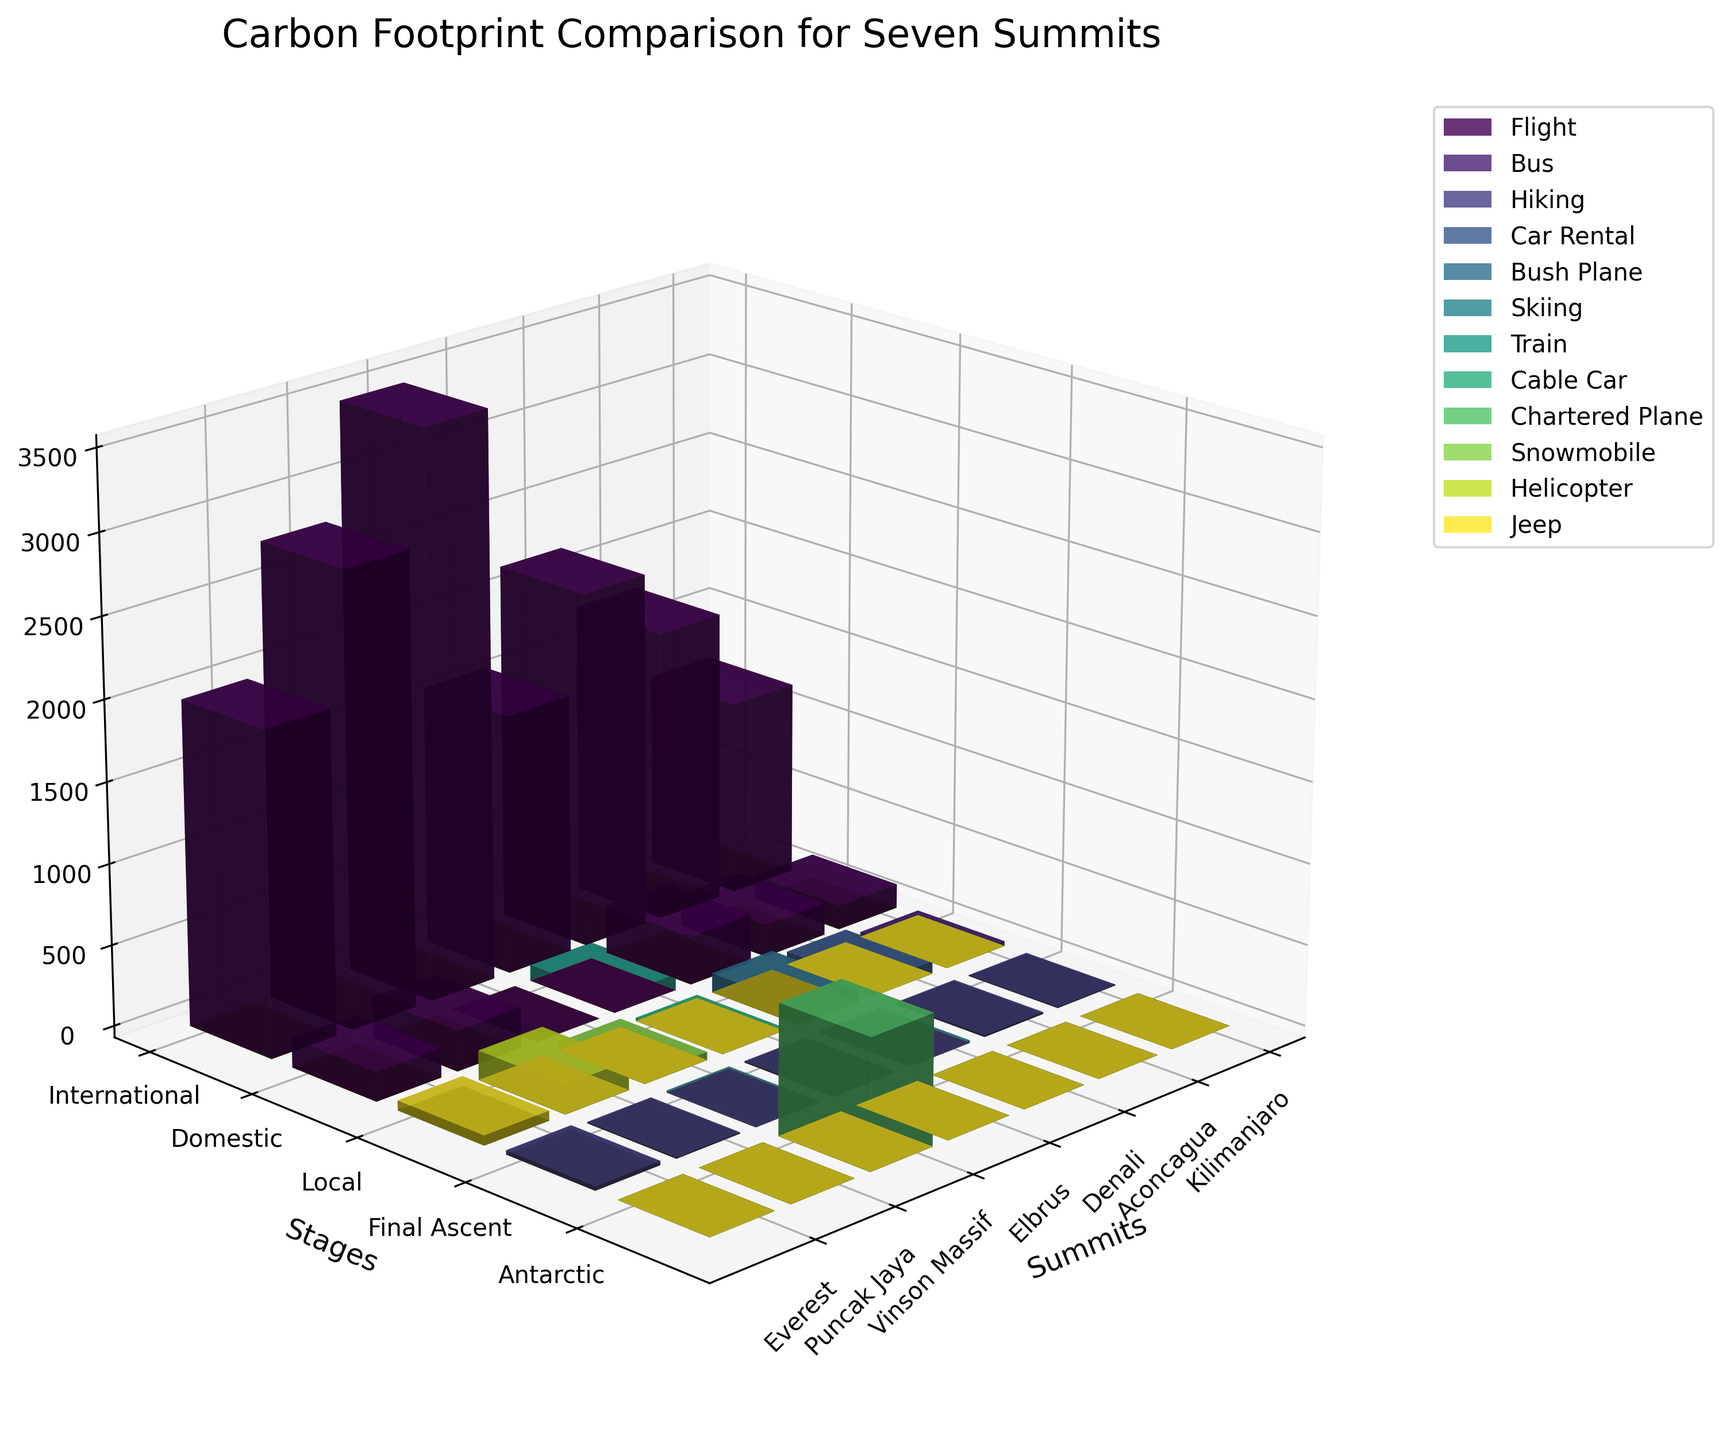1. What is the title of the figure? The title is generally displayed at the top of the figure, which helps in understanding the overall content being represented.
Answer: Carbon Footprint Comparison for Seven Summits 2. Which stage has the highest carbon footprint for Vinson Massif? By examining the bars corresponding to each stage for Vinson Massif, look for the tallest bar which represents the highest carbon footprint. The stages are labeled on the y-axis, and the carbon footprints are shown on the z-axis.
Answer: International 3. How does the carbon footprint of the Domestic Flight stage for Denali compare to that of Everest? Find the bars corresponding to the Domestic Flight stage for both Denali and Everest, and compare their heights as depicted from the base to the top in the z-axis.
Answer: Denali's Domestic Flight has a higher carbon footprint than Everest 4. Which transport method contributes the least carbon footprint when climbing Kilimanjaro? Identify the shortest bar for Kilimanjaro across all transport methods, as the shortest bar represents the minimum carbon footprint. Verify by checking the colors in the legend.
Answer: Hiking 5. What is the combined carbon footprint for all stages when climbing Elbrus? Sum the heights of the bars for Elbrus across all stages listed: International Flight, Domestic Train, Local Cable Car, and Final Ascent Hiking. Their contributions are shown on the z-axis in kg CO2e.
Answer: 1720 kg CO2e 6. Which summit has the highest carbon footprint from Local transport methods? Compare the heights of the bars representing local transport methods (e.g., Bus, Car Rental, Bush Plane, Cable Car, Snowmobile, Helicopter, Jeep) across all summits to identify the tallest.
Answer: Puncak Jaya 7. How do the carbon footprints of the Final Ascent stage vary across summits? Look at the bars for the Final Ascent stage for each summit listed, observe and note the differences in their heights.
Answer: Kilimanjaro: 5, Aconcagua: 10, Denali: 15, Elbrus: 8, Vinson Massif: 12, Puncak Jaya: 7, Everest: 25 8. What is the total carbon footprint for the International Flight stage across all summits? Find the bars representing the International Flight stage for each summit, sum the heights, which represent their respective carbon footprints.
Answer: 15100 kg CO2e 9. How much greater is the carbon footprint of Vinson Massif’s International Flight compared to Kilimanjaro’s International Flight? Find the heights of the International Flight bars for Vinson Massif and Kilimanjaro, calculate the difference between them. The values can be read directly from the z-axis.
Answer: 2300 kg CO2e 10. Which summit has the most evenly distributed carbon footprint across all stages? Examine the bars for each summit and compare the variances in height for each stage; the one with the least variance is the most evenly distributed.
Answer: Elbrus 